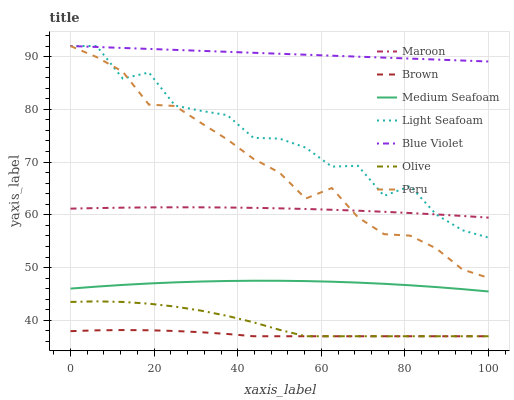Does Brown have the minimum area under the curve?
Answer yes or no. Yes. Does Blue Violet have the maximum area under the curve?
Answer yes or no. Yes. Does Maroon have the minimum area under the curve?
Answer yes or no. No. Does Maroon have the maximum area under the curve?
Answer yes or no. No. Is Blue Violet the smoothest?
Answer yes or no. Yes. Is Light Seafoam the roughest?
Answer yes or no. Yes. Is Maroon the smoothest?
Answer yes or no. No. Is Maroon the roughest?
Answer yes or no. No. Does Brown have the lowest value?
Answer yes or no. Yes. Does Maroon have the lowest value?
Answer yes or no. No. Does Blue Violet have the highest value?
Answer yes or no. Yes. Does Maroon have the highest value?
Answer yes or no. No. Is Medium Seafoam less than Peru?
Answer yes or no. Yes. Is Maroon greater than Olive?
Answer yes or no. Yes. Does Light Seafoam intersect Blue Violet?
Answer yes or no. Yes. Is Light Seafoam less than Blue Violet?
Answer yes or no. No. Is Light Seafoam greater than Blue Violet?
Answer yes or no. No. Does Medium Seafoam intersect Peru?
Answer yes or no. No. 